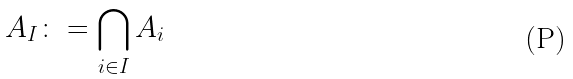<formula> <loc_0><loc_0><loc_500><loc_500>A _ { I } \colon = \bigcap _ { i \in I } A _ { i }</formula> 